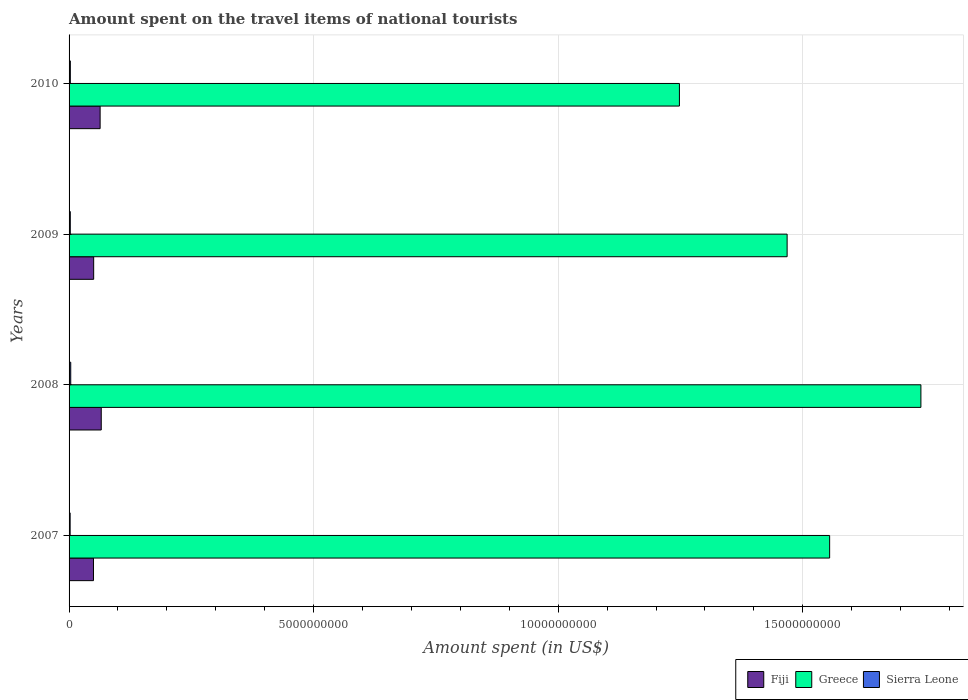How many bars are there on the 3rd tick from the top?
Your response must be concise. 3. What is the label of the 4th group of bars from the top?
Provide a short and direct response. 2007. In how many cases, is the number of bars for a given year not equal to the number of legend labels?
Your answer should be very brief. 0. What is the amount spent on the travel items of national tourists in Greece in 2007?
Ensure brevity in your answer.  1.56e+1. Across all years, what is the maximum amount spent on the travel items of national tourists in Fiji?
Offer a very short reply. 6.58e+08. Across all years, what is the minimum amount spent on the travel items of national tourists in Sierra Leone?
Offer a very short reply. 2.20e+07. In which year was the amount spent on the travel items of national tourists in Greece minimum?
Your answer should be very brief. 2010. What is the total amount spent on the travel items of national tourists in Fiji in the graph?
Keep it short and to the point. 2.30e+09. What is the difference between the amount spent on the travel items of national tourists in Greece in 2007 and that in 2009?
Keep it short and to the point. 8.69e+08. What is the difference between the amount spent on the travel items of national tourists in Greece in 2010 and the amount spent on the travel items of national tourists in Sierra Leone in 2007?
Keep it short and to the point. 1.25e+1. What is the average amount spent on the travel items of national tourists in Greece per year?
Your response must be concise. 1.50e+1. In the year 2008, what is the difference between the amount spent on the travel items of national tourists in Fiji and amount spent on the travel items of national tourists in Greece?
Offer a very short reply. -1.68e+1. In how many years, is the amount spent on the travel items of national tourists in Fiji greater than 9000000000 US$?
Your answer should be very brief. 0. What is the ratio of the amount spent on the travel items of national tourists in Sierra Leone in 2007 to that in 2008?
Provide a succinct answer. 0.65. Is the amount spent on the travel items of national tourists in Fiji in 2007 less than that in 2010?
Your response must be concise. Yes. What is the difference between the highest and the second highest amount spent on the travel items of national tourists in Fiji?
Your response must be concise. 2.30e+07. What is the difference between the highest and the lowest amount spent on the travel items of national tourists in Fiji?
Make the answer very short. 1.59e+08. What does the 2nd bar from the top in 2010 represents?
Provide a succinct answer. Greece. What does the 1st bar from the bottom in 2010 represents?
Keep it short and to the point. Fiji. Is it the case that in every year, the sum of the amount spent on the travel items of national tourists in Fiji and amount spent on the travel items of national tourists in Greece is greater than the amount spent on the travel items of national tourists in Sierra Leone?
Give a very brief answer. Yes. Are the values on the major ticks of X-axis written in scientific E-notation?
Give a very brief answer. No. Does the graph contain grids?
Your response must be concise. Yes. How are the legend labels stacked?
Give a very brief answer. Horizontal. What is the title of the graph?
Keep it short and to the point. Amount spent on the travel items of national tourists. What is the label or title of the X-axis?
Provide a short and direct response. Amount spent (in US$). What is the Amount spent (in US$) of Fiji in 2007?
Offer a terse response. 4.99e+08. What is the Amount spent (in US$) in Greece in 2007?
Offer a terse response. 1.56e+1. What is the Amount spent (in US$) of Sierra Leone in 2007?
Provide a succinct answer. 2.20e+07. What is the Amount spent (in US$) of Fiji in 2008?
Make the answer very short. 6.58e+08. What is the Amount spent (in US$) of Greece in 2008?
Keep it short and to the point. 1.74e+1. What is the Amount spent (in US$) in Sierra Leone in 2008?
Provide a short and direct response. 3.40e+07. What is the Amount spent (in US$) of Fiji in 2009?
Your answer should be compact. 5.03e+08. What is the Amount spent (in US$) of Greece in 2009?
Make the answer very short. 1.47e+1. What is the Amount spent (in US$) in Sierra Leone in 2009?
Provide a succinct answer. 2.50e+07. What is the Amount spent (in US$) of Fiji in 2010?
Make the answer very short. 6.35e+08. What is the Amount spent (in US$) of Greece in 2010?
Keep it short and to the point. 1.25e+1. What is the Amount spent (in US$) of Sierra Leone in 2010?
Offer a very short reply. 2.60e+07. Across all years, what is the maximum Amount spent (in US$) of Fiji?
Offer a terse response. 6.58e+08. Across all years, what is the maximum Amount spent (in US$) in Greece?
Your response must be concise. 1.74e+1. Across all years, what is the maximum Amount spent (in US$) in Sierra Leone?
Provide a short and direct response. 3.40e+07. Across all years, what is the minimum Amount spent (in US$) of Fiji?
Give a very brief answer. 4.99e+08. Across all years, what is the minimum Amount spent (in US$) of Greece?
Ensure brevity in your answer.  1.25e+1. Across all years, what is the minimum Amount spent (in US$) of Sierra Leone?
Make the answer very short. 2.20e+07. What is the total Amount spent (in US$) in Fiji in the graph?
Your answer should be very brief. 2.30e+09. What is the total Amount spent (in US$) of Greece in the graph?
Give a very brief answer. 6.01e+1. What is the total Amount spent (in US$) of Sierra Leone in the graph?
Make the answer very short. 1.07e+08. What is the difference between the Amount spent (in US$) in Fiji in 2007 and that in 2008?
Keep it short and to the point. -1.59e+08. What is the difference between the Amount spent (in US$) in Greece in 2007 and that in 2008?
Ensure brevity in your answer.  -1.87e+09. What is the difference between the Amount spent (in US$) in Sierra Leone in 2007 and that in 2008?
Your response must be concise. -1.20e+07. What is the difference between the Amount spent (in US$) in Greece in 2007 and that in 2009?
Offer a very short reply. 8.69e+08. What is the difference between the Amount spent (in US$) of Sierra Leone in 2007 and that in 2009?
Provide a short and direct response. -3.00e+06. What is the difference between the Amount spent (in US$) of Fiji in 2007 and that in 2010?
Make the answer very short. -1.36e+08. What is the difference between the Amount spent (in US$) of Greece in 2007 and that in 2010?
Provide a succinct answer. 3.07e+09. What is the difference between the Amount spent (in US$) in Sierra Leone in 2007 and that in 2010?
Your answer should be very brief. -4.00e+06. What is the difference between the Amount spent (in US$) in Fiji in 2008 and that in 2009?
Ensure brevity in your answer.  1.55e+08. What is the difference between the Amount spent (in US$) in Greece in 2008 and that in 2009?
Ensure brevity in your answer.  2.74e+09. What is the difference between the Amount spent (in US$) in Sierra Leone in 2008 and that in 2009?
Offer a very short reply. 9.00e+06. What is the difference between the Amount spent (in US$) of Fiji in 2008 and that in 2010?
Provide a short and direct response. 2.30e+07. What is the difference between the Amount spent (in US$) of Greece in 2008 and that in 2010?
Give a very brief answer. 4.94e+09. What is the difference between the Amount spent (in US$) in Fiji in 2009 and that in 2010?
Make the answer very short. -1.32e+08. What is the difference between the Amount spent (in US$) in Greece in 2009 and that in 2010?
Offer a very short reply. 2.20e+09. What is the difference between the Amount spent (in US$) in Fiji in 2007 and the Amount spent (in US$) in Greece in 2008?
Give a very brief answer. -1.69e+1. What is the difference between the Amount spent (in US$) in Fiji in 2007 and the Amount spent (in US$) in Sierra Leone in 2008?
Provide a short and direct response. 4.65e+08. What is the difference between the Amount spent (in US$) of Greece in 2007 and the Amount spent (in US$) of Sierra Leone in 2008?
Make the answer very short. 1.55e+1. What is the difference between the Amount spent (in US$) of Fiji in 2007 and the Amount spent (in US$) of Greece in 2009?
Offer a terse response. -1.42e+1. What is the difference between the Amount spent (in US$) in Fiji in 2007 and the Amount spent (in US$) in Sierra Leone in 2009?
Ensure brevity in your answer.  4.74e+08. What is the difference between the Amount spent (in US$) of Greece in 2007 and the Amount spent (in US$) of Sierra Leone in 2009?
Offer a very short reply. 1.55e+1. What is the difference between the Amount spent (in US$) of Fiji in 2007 and the Amount spent (in US$) of Greece in 2010?
Provide a short and direct response. -1.20e+1. What is the difference between the Amount spent (in US$) of Fiji in 2007 and the Amount spent (in US$) of Sierra Leone in 2010?
Ensure brevity in your answer.  4.73e+08. What is the difference between the Amount spent (in US$) in Greece in 2007 and the Amount spent (in US$) in Sierra Leone in 2010?
Ensure brevity in your answer.  1.55e+1. What is the difference between the Amount spent (in US$) in Fiji in 2008 and the Amount spent (in US$) in Greece in 2009?
Your answer should be compact. -1.40e+1. What is the difference between the Amount spent (in US$) in Fiji in 2008 and the Amount spent (in US$) in Sierra Leone in 2009?
Offer a terse response. 6.33e+08. What is the difference between the Amount spent (in US$) of Greece in 2008 and the Amount spent (in US$) of Sierra Leone in 2009?
Make the answer very short. 1.74e+1. What is the difference between the Amount spent (in US$) in Fiji in 2008 and the Amount spent (in US$) in Greece in 2010?
Make the answer very short. -1.18e+1. What is the difference between the Amount spent (in US$) in Fiji in 2008 and the Amount spent (in US$) in Sierra Leone in 2010?
Ensure brevity in your answer.  6.32e+08. What is the difference between the Amount spent (in US$) of Greece in 2008 and the Amount spent (in US$) of Sierra Leone in 2010?
Offer a very short reply. 1.74e+1. What is the difference between the Amount spent (in US$) in Fiji in 2009 and the Amount spent (in US$) in Greece in 2010?
Your answer should be compact. -1.20e+1. What is the difference between the Amount spent (in US$) in Fiji in 2009 and the Amount spent (in US$) in Sierra Leone in 2010?
Offer a terse response. 4.77e+08. What is the difference between the Amount spent (in US$) in Greece in 2009 and the Amount spent (in US$) in Sierra Leone in 2010?
Keep it short and to the point. 1.47e+1. What is the average Amount spent (in US$) of Fiji per year?
Your response must be concise. 5.74e+08. What is the average Amount spent (in US$) of Greece per year?
Provide a succinct answer. 1.50e+1. What is the average Amount spent (in US$) in Sierra Leone per year?
Your response must be concise. 2.68e+07. In the year 2007, what is the difference between the Amount spent (in US$) in Fiji and Amount spent (in US$) in Greece?
Provide a succinct answer. -1.51e+1. In the year 2007, what is the difference between the Amount spent (in US$) of Fiji and Amount spent (in US$) of Sierra Leone?
Offer a terse response. 4.77e+08. In the year 2007, what is the difference between the Amount spent (in US$) in Greece and Amount spent (in US$) in Sierra Leone?
Make the answer very short. 1.55e+1. In the year 2008, what is the difference between the Amount spent (in US$) of Fiji and Amount spent (in US$) of Greece?
Provide a succinct answer. -1.68e+1. In the year 2008, what is the difference between the Amount spent (in US$) in Fiji and Amount spent (in US$) in Sierra Leone?
Offer a terse response. 6.24e+08. In the year 2008, what is the difference between the Amount spent (in US$) in Greece and Amount spent (in US$) in Sierra Leone?
Give a very brief answer. 1.74e+1. In the year 2009, what is the difference between the Amount spent (in US$) of Fiji and Amount spent (in US$) of Greece?
Ensure brevity in your answer.  -1.42e+1. In the year 2009, what is the difference between the Amount spent (in US$) in Fiji and Amount spent (in US$) in Sierra Leone?
Make the answer very short. 4.78e+08. In the year 2009, what is the difference between the Amount spent (in US$) of Greece and Amount spent (in US$) of Sierra Leone?
Your answer should be very brief. 1.47e+1. In the year 2010, what is the difference between the Amount spent (in US$) of Fiji and Amount spent (in US$) of Greece?
Offer a terse response. -1.18e+1. In the year 2010, what is the difference between the Amount spent (in US$) of Fiji and Amount spent (in US$) of Sierra Leone?
Keep it short and to the point. 6.09e+08. In the year 2010, what is the difference between the Amount spent (in US$) in Greece and Amount spent (in US$) in Sierra Leone?
Keep it short and to the point. 1.25e+1. What is the ratio of the Amount spent (in US$) in Fiji in 2007 to that in 2008?
Provide a short and direct response. 0.76. What is the ratio of the Amount spent (in US$) of Greece in 2007 to that in 2008?
Provide a succinct answer. 0.89. What is the ratio of the Amount spent (in US$) in Sierra Leone in 2007 to that in 2008?
Make the answer very short. 0.65. What is the ratio of the Amount spent (in US$) in Greece in 2007 to that in 2009?
Ensure brevity in your answer.  1.06. What is the ratio of the Amount spent (in US$) in Sierra Leone in 2007 to that in 2009?
Offer a terse response. 0.88. What is the ratio of the Amount spent (in US$) in Fiji in 2007 to that in 2010?
Give a very brief answer. 0.79. What is the ratio of the Amount spent (in US$) of Greece in 2007 to that in 2010?
Your answer should be very brief. 1.25. What is the ratio of the Amount spent (in US$) in Sierra Leone in 2007 to that in 2010?
Provide a short and direct response. 0.85. What is the ratio of the Amount spent (in US$) of Fiji in 2008 to that in 2009?
Provide a short and direct response. 1.31. What is the ratio of the Amount spent (in US$) of Greece in 2008 to that in 2009?
Your answer should be compact. 1.19. What is the ratio of the Amount spent (in US$) of Sierra Leone in 2008 to that in 2009?
Provide a short and direct response. 1.36. What is the ratio of the Amount spent (in US$) in Fiji in 2008 to that in 2010?
Offer a terse response. 1.04. What is the ratio of the Amount spent (in US$) of Greece in 2008 to that in 2010?
Make the answer very short. 1.4. What is the ratio of the Amount spent (in US$) of Sierra Leone in 2008 to that in 2010?
Your answer should be very brief. 1.31. What is the ratio of the Amount spent (in US$) in Fiji in 2009 to that in 2010?
Your answer should be compact. 0.79. What is the ratio of the Amount spent (in US$) in Greece in 2009 to that in 2010?
Your answer should be compact. 1.18. What is the ratio of the Amount spent (in US$) in Sierra Leone in 2009 to that in 2010?
Provide a succinct answer. 0.96. What is the difference between the highest and the second highest Amount spent (in US$) in Fiji?
Your answer should be very brief. 2.30e+07. What is the difference between the highest and the second highest Amount spent (in US$) of Greece?
Provide a succinct answer. 1.87e+09. What is the difference between the highest and the second highest Amount spent (in US$) in Sierra Leone?
Your answer should be very brief. 8.00e+06. What is the difference between the highest and the lowest Amount spent (in US$) in Fiji?
Offer a very short reply. 1.59e+08. What is the difference between the highest and the lowest Amount spent (in US$) of Greece?
Give a very brief answer. 4.94e+09. 